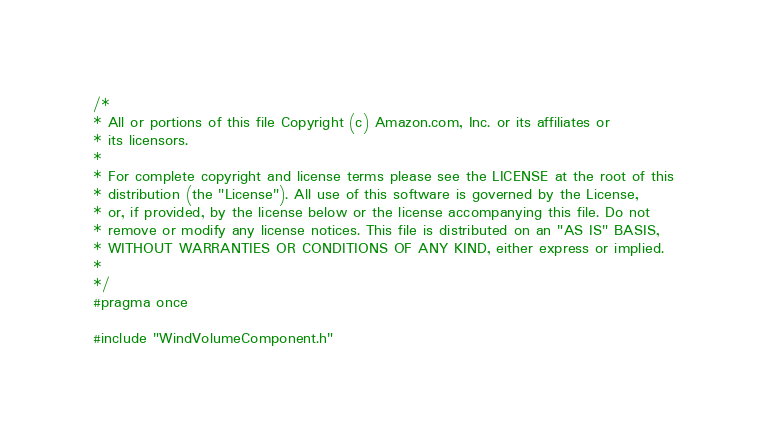<code> <loc_0><loc_0><loc_500><loc_500><_C_>/*
* All or portions of this file Copyright (c) Amazon.com, Inc. or its affiliates or
* its licensors.
*
* For complete copyright and license terms please see the LICENSE at the root of this
* distribution (the "License"). All use of this software is governed by the License,
* or, if provided, by the license below or the license accompanying this file. Do not
* remove or modify any license notices. This file is distributed on an "AS IS" BASIS,
* WITHOUT WARRANTIES OR CONDITIONS OF ANY KIND, either express or implied.
*
*/
#pragma once

#include "WindVolumeComponent.h"</code> 